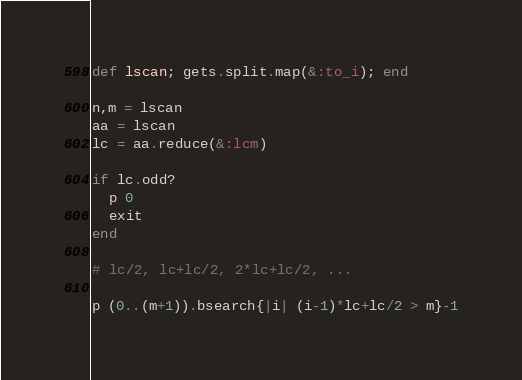Convert code to text. <code><loc_0><loc_0><loc_500><loc_500><_Ruby_>def lscan; gets.split.map(&:to_i); end

n,m = lscan
aa = lscan
lc = aa.reduce(&:lcm)

if lc.odd?
  p 0
  exit
end

# lc/2, lc+lc/2, 2*lc+lc/2, ...

p (0..(m+1)).bsearch{|i| (i-1)*lc+lc/2 > m}-1</code> 